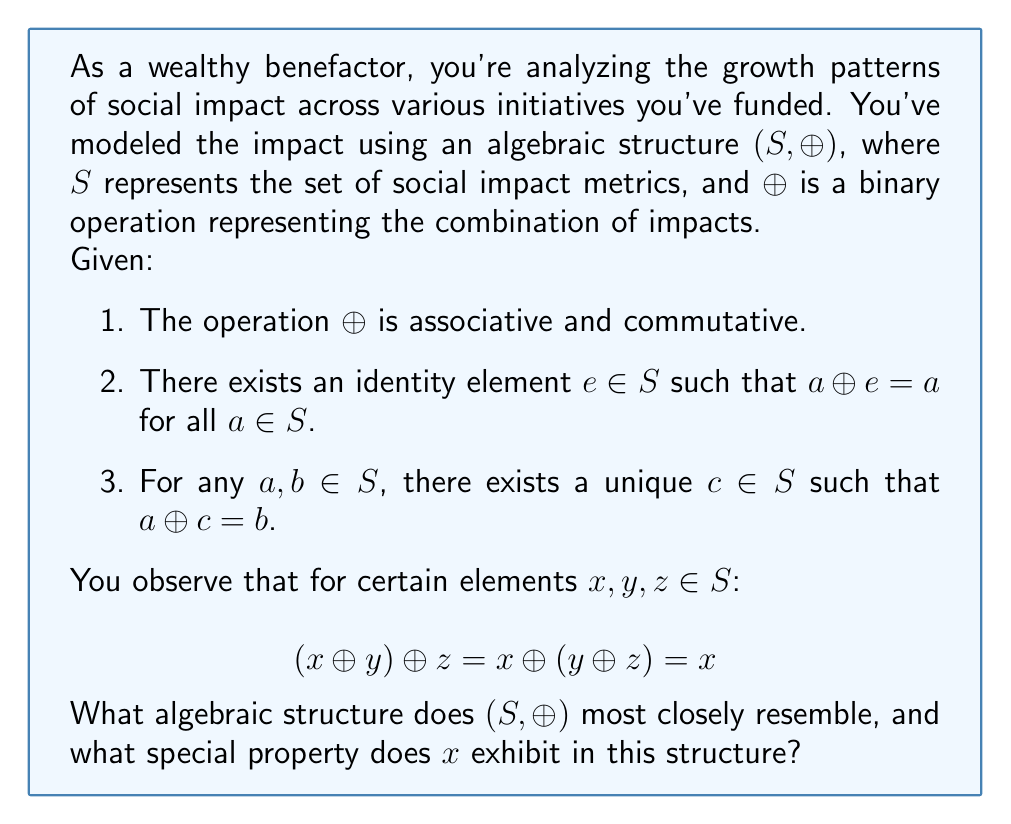Help me with this question. Let's analyze this step-by-step:

1) First, we need to identify the properties of the algebraic structure $(S, \oplus)$:
   - $\oplus$ is associative and commutative
   - There exists an identity element $e$
   - For any two elements, there exists a unique third element that combines with one to produce the other (this implies the existence of inverse elements)

2) These properties match the definition of an Abelian group. The set $S$ with the operation $\oplus$ forms an Abelian group.

3) Now, let's look at the given equation:

   $$(x \oplus y) \oplus z = x \oplus (y \oplus z) = x$$

4) In group theory, this equation suggests that $x$ is idempotent under the operation $\oplus$. An idempotent element is one that, when combined with itself under the group operation, produces itself.

5) To prove this, let's consider the right side of the equation:

   $x \oplus (y \oplus z) = x$

   This implies that $y \oplus z$ must be the identity element $e$, because only the identity element, when combined with $x$, would produce $x$.

6) So we can write:

   $x \oplus e = x$

7) Now, if we replace $e$ with $x$ in this equation:

   $x \oplus x = x$

   This is the definition of an idempotent element.

8) In an Abelian group, the only idempotent element is the identity element itself. This means that $x$ must be the identity element $e$ of the group.

Therefore, $(S, \oplus)$ most closely resembles an Abelian group, and $x$ exhibits the property of being the identity element of this group.
Answer: Abelian group; identity element 